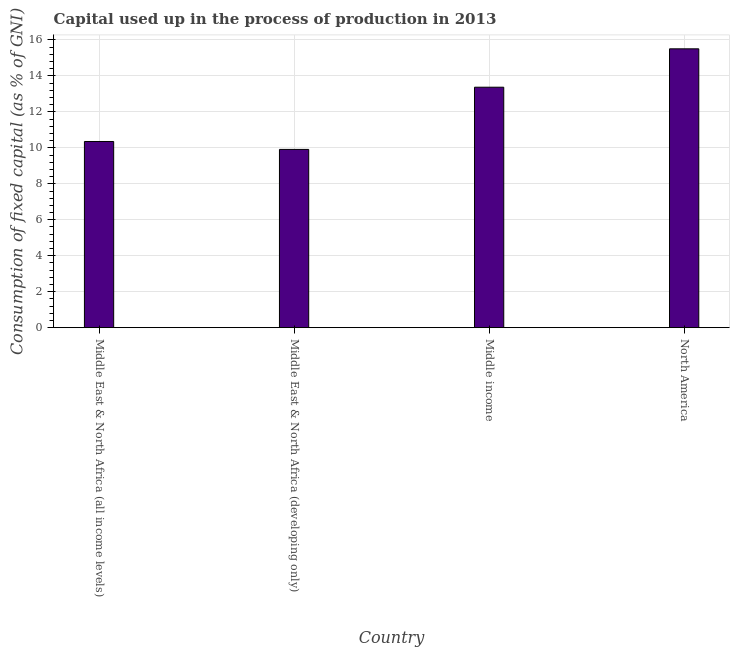Does the graph contain any zero values?
Offer a very short reply. No. Does the graph contain grids?
Offer a very short reply. Yes. What is the title of the graph?
Ensure brevity in your answer.  Capital used up in the process of production in 2013. What is the label or title of the X-axis?
Provide a short and direct response. Country. What is the label or title of the Y-axis?
Offer a terse response. Consumption of fixed capital (as % of GNI). What is the consumption of fixed capital in Middle income?
Ensure brevity in your answer.  13.37. Across all countries, what is the maximum consumption of fixed capital?
Your response must be concise. 15.51. Across all countries, what is the minimum consumption of fixed capital?
Your answer should be very brief. 9.91. In which country was the consumption of fixed capital minimum?
Your answer should be compact. Middle East & North Africa (developing only). What is the sum of the consumption of fixed capital?
Your response must be concise. 49.15. What is the difference between the consumption of fixed capital in Middle East & North Africa (developing only) and Middle income?
Provide a short and direct response. -3.46. What is the average consumption of fixed capital per country?
Offer a very short reply. 12.29. What is the median consumption of fixed capital?
Your answer should be compact. 11.86. What is the ratio of the consumption of fixed capital in Middle income to that in North America?
Your response must be concise. 0.86. Is the difference between the consumption of fixed capital in Middle East & North Africa (all income levels) and Middle income greater than the difference between any two countries?
Ensure brevity in your answer.  No. What is the difference between the highest and the second highest consumption of fixed capital?
Give a very brief answer. 2.14. Is the sum of the consumption of fixed capital in Middle East & North Africa (developing only) and Middle income greater than the maximum consumption of fixed capital across all countries?
Offer a very short reply. Yes. What is the difference between the highest and the lowest consumption of fixed capital?
Keep it short and to the point. 5.59. Are the values on the major ticks of Y-axis written in scientific E-notation?
Make the answer very short. No. What is the Consumption of fixed capital (as % of GNI) in Middle East & North Africa (all income levels)?
Make the answer very short. 10.35. What is the Consumption of fixed capital (as % of GNI) in Middle East & North Africa (developing only)?
Keep it short and to the point. 9.91. What is the Consumption of fixed capital (as % of GNI) of Middle income?
Your response must be concise. 13.37. What is the Consumption of fixed capital (as % of GNI) in North America?
Offer a terse response. 15.51. What is the difference between the Consumption of fixed capital (as % of GNI) in Middle East & North Africa (all income levels) and Middle East & North Africa (developing only)?
Offer a terse response. 0.44. What is the difference between the Consumption of fixed capital (as % of GNI) in Middle East & North Africa (all income levels) and Middle income?
Your answer should be compact. -3.02. What is the difference between the Consumption of fixed capital (as % of GNI) in Middle East & North Africa (all income levels) and North America?
Your response must be concise. -5.15. What is the difference between the Consumption of fixed capital (as % of GNI) in Middle East & North Africa (developing only) and Middle income?
Provide a short and direct response. -3.46. What is the difference between the Consumption of fixed capital (as % of GNI) in Middle East & North Africa (developing only) and North America?
Your response must be concise. -5.59. What is the difference between the Consumption of fixed capital (as % of GNI) in Middle income and North America?
Provide a succinct answer. -2.14. What is the ratio of the Consumption of fixed capital (as % of GNI) in Middle East & North Africa (all income levels) to that in Middle East & North Africa (developing only)?
Provide a succinct answer. 1.04. What is the ratio of the Consumption of fixed capital (as % of GNI) in Middle East & North Africa (all income levels) to that in Middle income?
Provide a short and direct response. 0.77. What is the ratio of the Consumption of fixed capital (as % of GNI) in Middle East & North Africa (all income levels) to that in North America?
Give a very brief answer. 0.67. What is the ratio of the Consumption of fixed capital (as % of GNI) in Middle East & North Africa (developing only) to that in Middle income?
Keep it short and to the point. 0.74. What is the ratio of the Consumption of fixed capital (as % of GNI) in Middle East & North Africa (developing only) to that in North America?
Make the answer very short. 0.64. What is the ratio of the Consumption of fixed capital (as % of GNI) in Middle income to that in North America?
Your answer should be very brief. 0.86. 